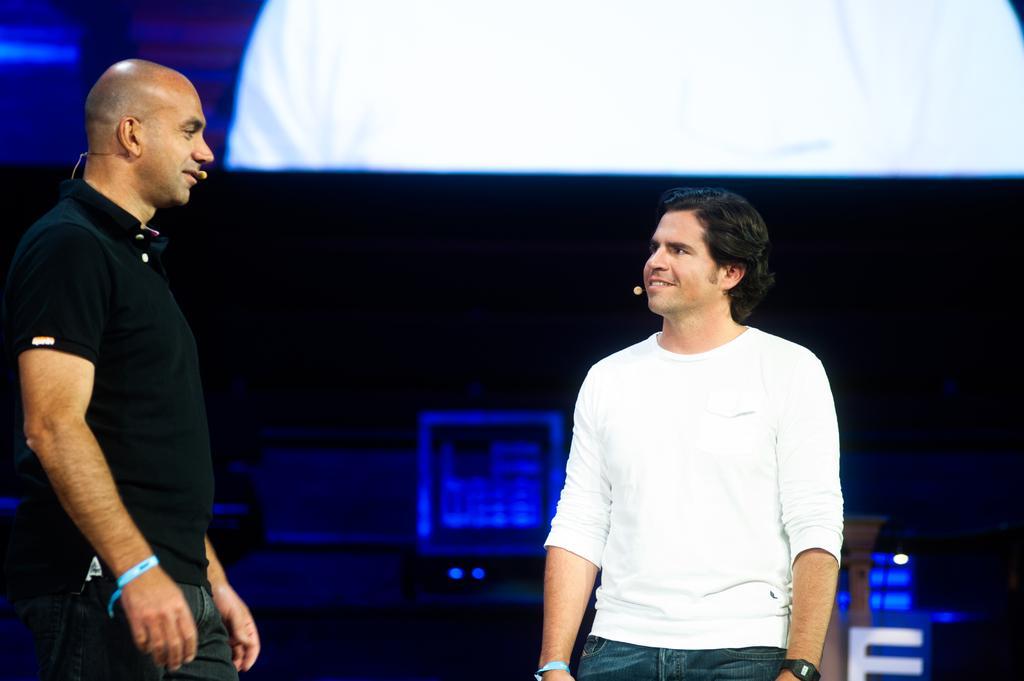Describe this image in one or two sentences. In this image we can see two men with smiling faces standing and wearing microphones. There is one white object at the top of the image, some objects in the background and the background is dark. 